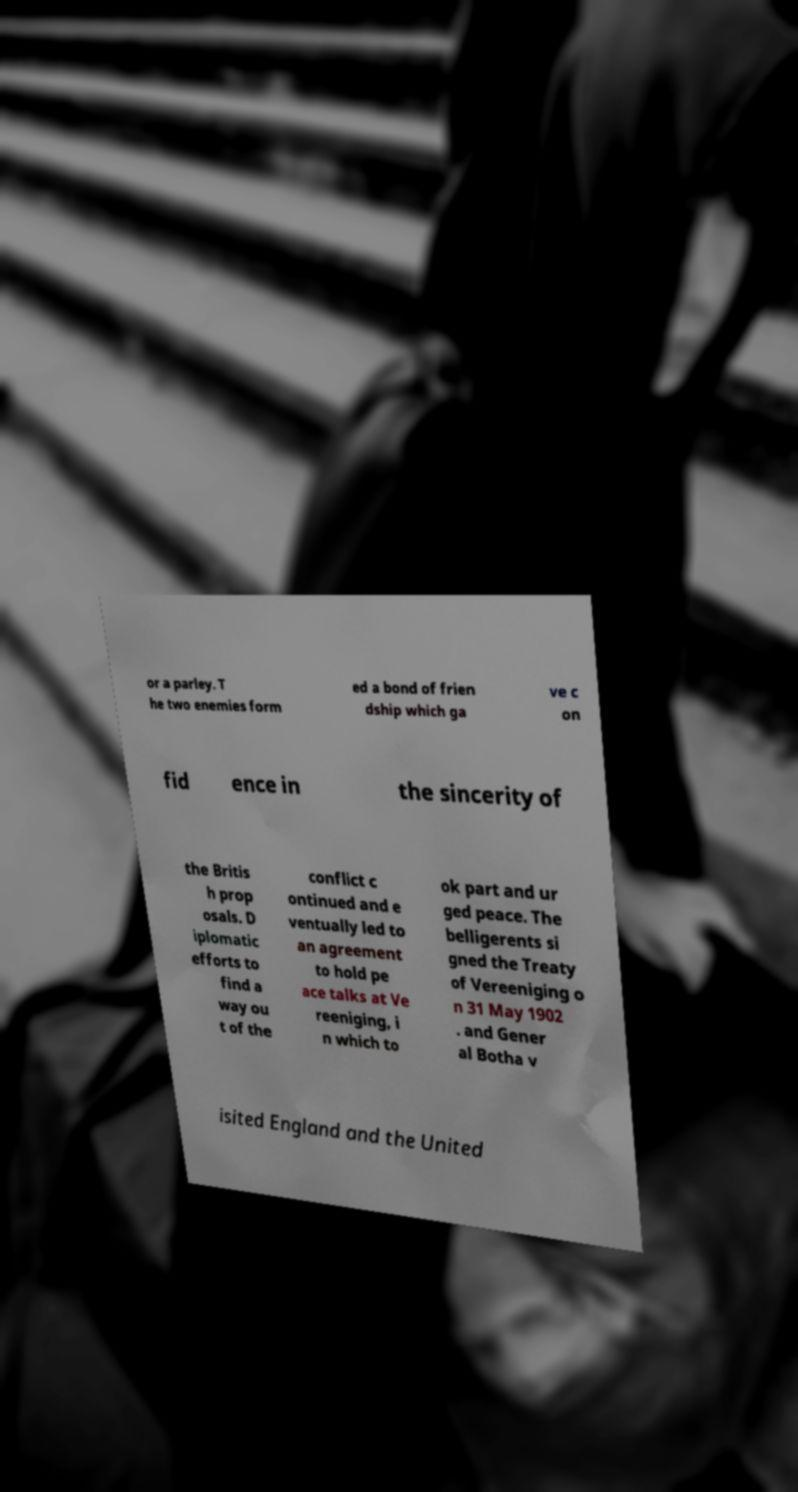I need the written content from this picture converted into text. Can you do that? or a parley. T he two enemies form ed a bond of frien dship which ga ve c on fid ence in the sincerity of the Britis h prop osals. D iplomatic efforts to find a way ou t of the conflict c ontinued and e ventually led to an agreement to hold pe ace talks at Ve reeniging, i n which to ok part and ur ged peace. The belligerents si gned the Treaty of Vereeniging o n 31 May 1902 . and Gener al Botha v isited England and the United 